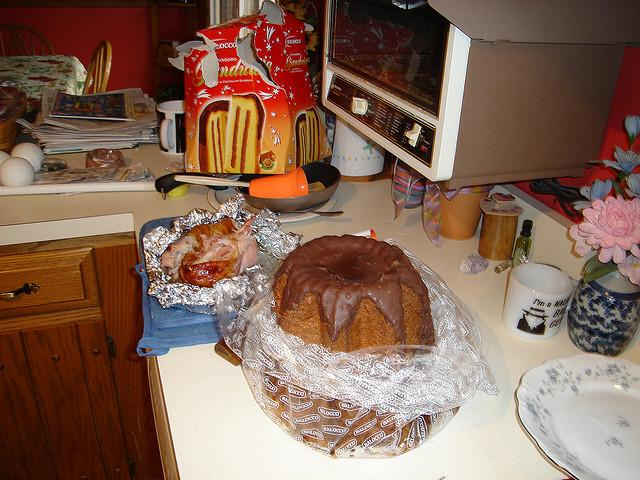What is the cake on top of?

Choices:
A) chair
B) babys head
C) counter
D) pizza box counter 